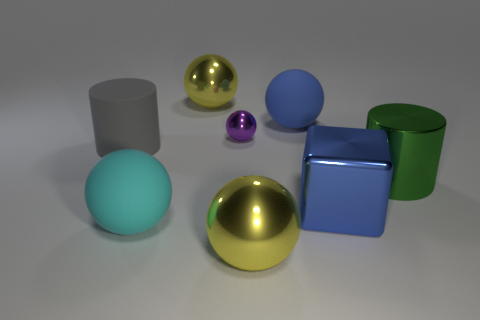Subtract all purple metal balls. How many balls are left? 4 Subtract all yellow cubes. How many yellow balls are left? 2 Subtract all blue spheres. How many spheres are left? 4 Add 1 small red cylinders. How many objects exist? 9 Subtract 1 balls. How many balls are left? 4 Subtract 1 gray cylinders. How many objects are left? 7 Subtract all balls. How many objects are left? 3 Subtract all yellow blocks. Subtract all blue cylinders. How many blocks are left? 1 Subtract all big blue blocks. Subtract all tiny cyan shiny balls. How many objects are left? 7 Add 8 big blue balls. How many big blue balls are left? 9 